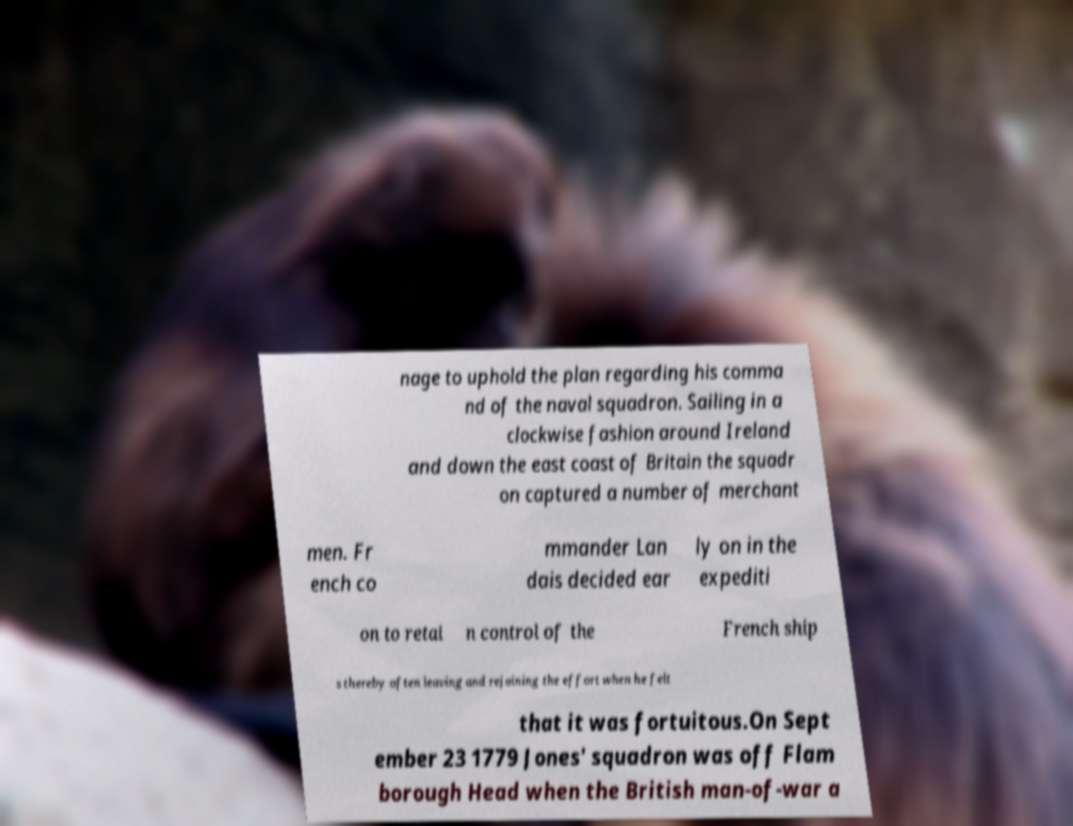I need the written content from this picture converted into text. Can you do that? nage to uphold the plan regarding his comma nd of the naval squadron. Sailing in a clockwise fashion around Ireland and down the east coast of Britain the squadr on captured a number of merchant men. Fr ench co mmander Lan dais decided ear ly on in the expediti on to retai n control of the French ship s thereby often leaving and rejoining the effort when he felt that it was fortuitous.On Sept ember 23 1779 Jones' squadron was off Flam borough Head when the British man-of-war a 